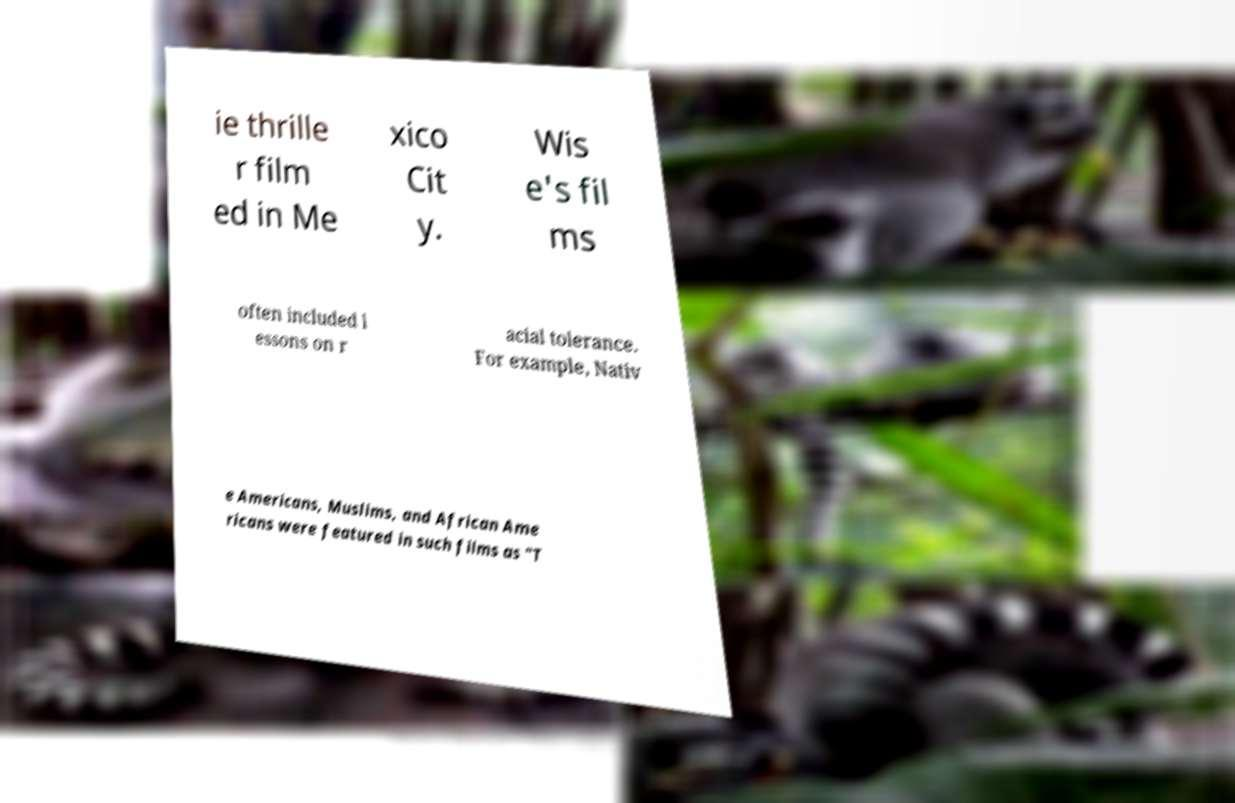Can you read and provide the text displayed in the image?This photo seems to have some interesting text. Can you extract and type it out for me? ie thrille r film ed in Me xico Cit y. Wis e's fil ms often included l essons on r acial tolerance. For example, Nativ e Americans, Muslims, and African Ame ricans were featured in such films as "T 